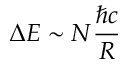<formula> <loc_0><loc_0><loc_500><loc_500>\Delta E \sim N \frac { \hbar { c } } { R }</formula> 